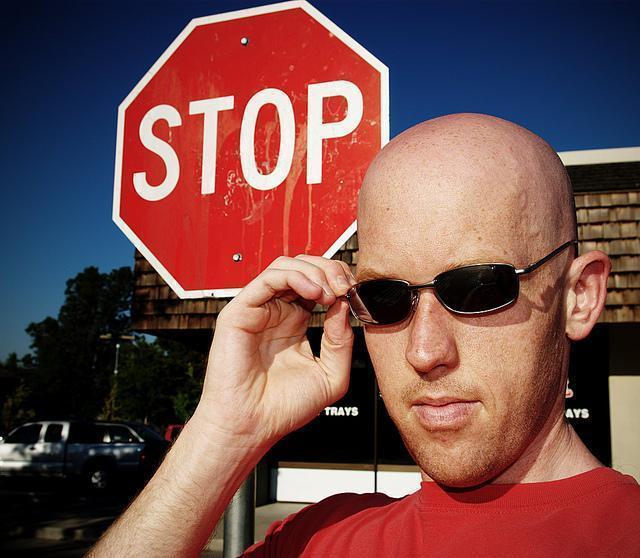This man most closely resembles who?
Select the accurate response from the four choices given to answer the question.
Options: Moby, chris rock, jimmy smits, sanjay gupta. Moby. 